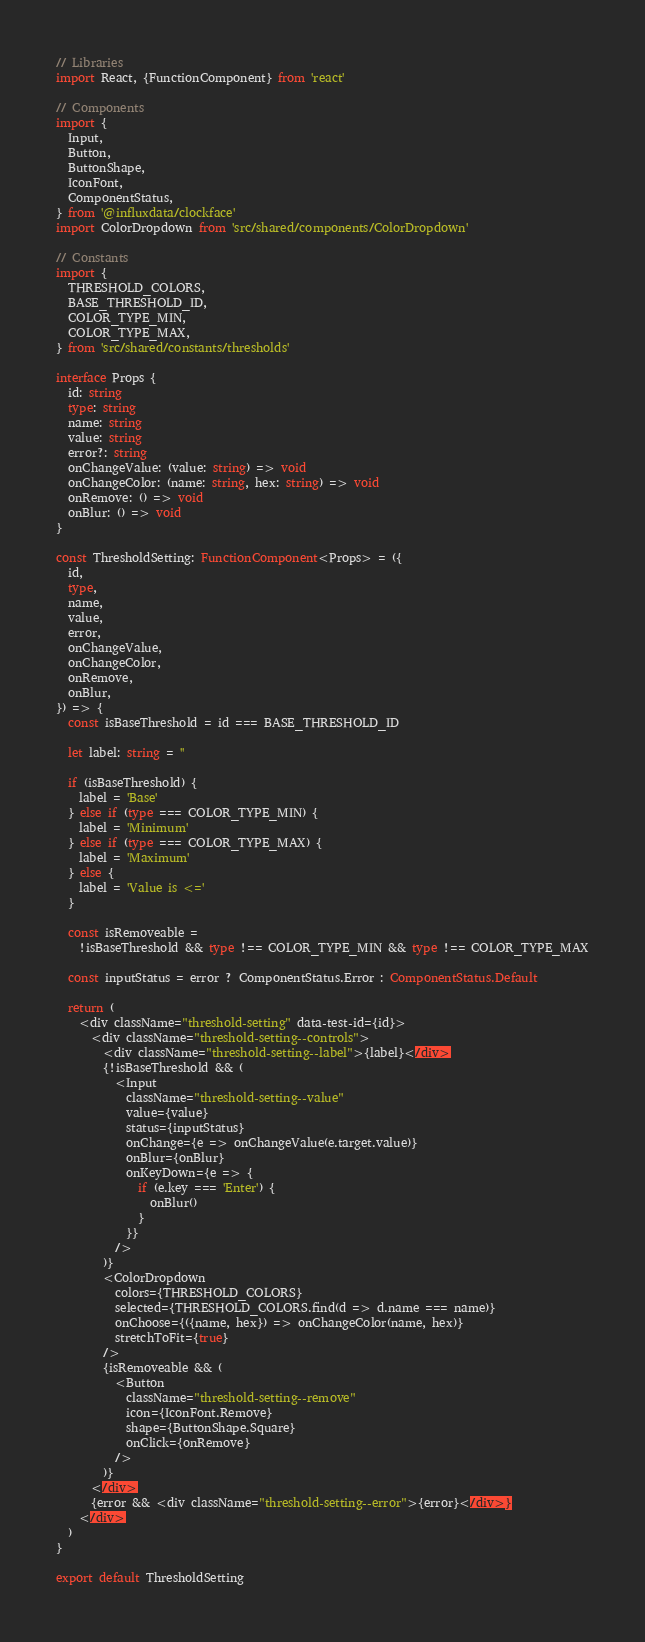Convert code to text. <code><loc_0><loc_0><loc_500><loc_500><_TypeScript_>// Libraries
import React, {FunctionComponent} from 'react'

// Components
import {
  Input,
  Button,
  ButtonShape,
  IconFont,
  ComponentStatus,
} from '@influxdata/clockface'
import ColorDropdown from 'src/shared/components/ColorDropdown'

// Constants
import {
  THRESHOLD_COLORS,
  BASE_THRESHOLD_ID,
  COLOR_TYPE_MIN,
  COLOR_TYPE_MAX,
} from 'src/shared/constants/thresholds'

interface Props {
  id: string
  type: string
  name: string
  value: string
  error?: string
  onChangeValue: (value: string) => void
  onChangeColor: (name: string, hex: string) => void
  onRemove: () => void
  onBlur: () => void
}

const ThresholdSetting: FunctionComponent<Props> = ({
  id,
  type,
  name,
  value,
  error,
  onChangeValue,
  onChangeColor,
  onRemove,
  onBlur,
}) => {
  const isBaseThreshold = id === BASE_THRESHOLD_ID

  let label: string = ''

  if (isBaseThreshold) {
    label = 'Base'
  } else if (type === COLOR_TYPE_MIN) {
    label = 'Minimum'
  } else if (type === COLOR_TYPE_MAX) {
    label = 'Maximum'
  } else {
    label = 'Value is <='
  }

  const isRemoveable =
    !isBaseThreshold && type !== COLOR_TYPE_MIN && type !== COLOR_TYPE_MAX

  const inputStatus = error ? ComponentStatus.Error : ComponentStatus.Default

  return (
    <div className="threshold-setting" data-test-id={id}>
      <div className="threshold-setting--controls">
        <div className="threshold-setting--label">{label}</div>
        {!isBaseThreshold && (
          <Input
            className="threshold-setting--value"
            value={value}
            status={inputStatus}
            onChange={e => onChangeValue(e.target.value)}
            onBlur={onBlur}
            onKeyDown={e => {
              if (e.key === 'Enter') {
                onBlur()
              }
            }}
          />
        )}
        <ColorDropdown
          colors={THRESHOLD_COLORS}
          selected={THRESHOLD_COLORS.find(d => d.name === name)}
          onChoose={({name, hex}) => onChangeColor(name, hex)}
          stretchToFit={true}
        />
        {isRemoveable && (
          <Button
            className="threshold-setting--remove"
            icon={IconFont.Remove}
            shape={ButtonShape.Square}
            onClick={onRemove}
          />
        )}
      </div>
      {error && <div className="threshold-setting--error">{error}</div>}
    </div>
  )
}

export default ThresholdSetting
</code> 